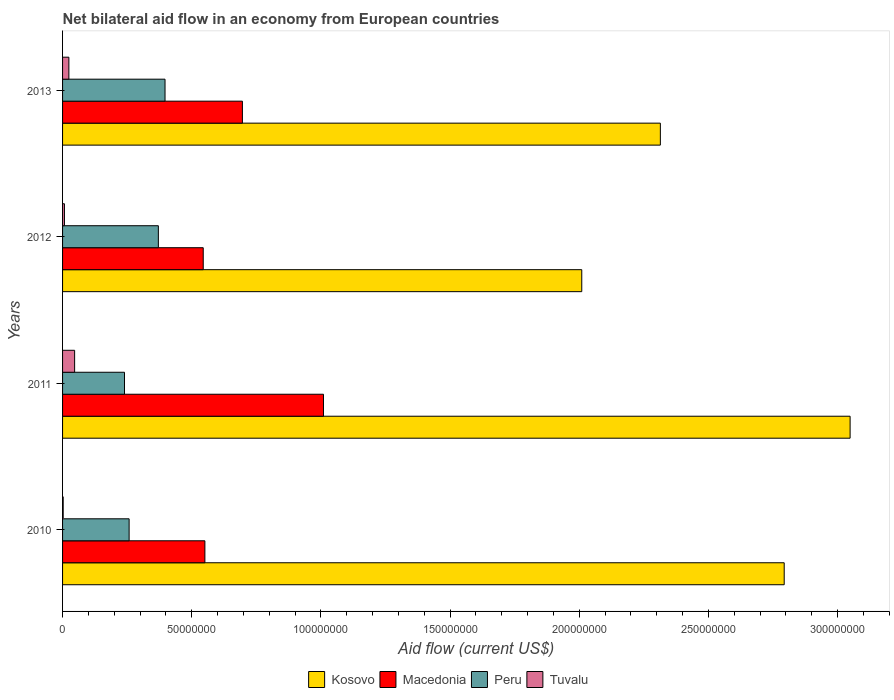How many different coloured bars are there?
Give a very brief answer. 4. How many groups of bars are there?
Keep it short and to the point. 4. Are the number of bars per tick equal to the number of legend labels?
Offer a very short reply. Yes. Are the number of bars on each tick of the Y-axis equal?
Your answer should be very brief. Yes. How many bars are there on the 1st tick from the top?
Make the answer very short. 4. How many bars are there on the 3rd tick from the bottom?
Your response must be concise. 4. What is the net bilateral aid flow in Macedonia in 2011?
Your answer should be very brief. 1.01e+08. Across all years, what is the maximum net bilateral aid flow in Kosovo?
Provide a short and direct response. 3.05e+08. Across all years, what is the minimum net bilateral aid flow in Macedonia?
Ensure brevity in your answer.  5.44e+07. In which year was the net bilateral aid flow in Peru maximum?
Give a very brief answer. 2013. In which year was the net bilateral aid flow in Peru minimum?
Give a very brief answer. 2011. What is the total net bilateral aid flow in Tuvalu in the graph?
Make the answer very short. 8.08e+06. What is the difference between the net bilateral aid flow in Peru in 2010 and that in 2012?
Make the answer very short. -1.13e+07. What is the difference between the net bilateral aid flow in Kosovo in 2013 and the net bilateral aid flow in Peru in 2012?
Your answer should be very brief. 1.94e+08. What is the average net bilateral aid flow in Macedonia per year?
Make the answer very short. 7.00e+07. In the year 2011, what is the difference between the net bilateral aid flow in Macedonia and net bilateral aid flow in Kosovo?
Offer a terse response. -2.04e+08. In how many years, is the net bilateral aid flow in Tuvalu greater than 260000000 US$?
Provide a succinct answer. 0. What is the ratio of the net bilateral aid flow in Macedonia in 2010 to that in 2013?
Offer a terse response. 0.79. Is the net bilateral aid flow in Tuvalu in 2010 less than that in 2013?
Offer a terse response. Yes. What is the difference between the highest and the second highest net bilateral aid flow in Peru?
Ensure brevity in your answer.  2.58e+06. What is the difference between the highest and the lowest net bilateral aid flow in Tuvalu?
Your answer should be very brief. 4.43e+06. Is the sum of the net bilateral aid flow in Kosovo in 2010 and 2011 greater than the maximum net bilateral aid flow in Macedonia across all years?
Ensure brevity in your answer.  Yes. What does the 3rd bar from the top in 2012 represents?
Ensure brevity in your answer.  Macedonia. What does the 2nd bar from the bottom in 2012 represents?
Provide a succinct answer. Macedonia. Is it the case that in every year, the sum of the net bilateral aid flow in Macedonia and net bilateral aid flow in Tuvalu is greater than the net bilateral aid flow in Kosovo?
Make the answer very short. No. How many bars are there?
Your answer should be very brief. 16. Are all the bars in the graph horizontal?
Make the answer very short. Yes. What is the difference between two consecutive major ticks on the X-axis?
Give a very brief answer. 5.00e+07. Are the values on the major ticks of X-axis written in scientific E-notation?
Provide a short and direct response. No. Does the graph contain grids?
Your response must be concise. No. How many legend labels are there?
Give a very brief answer. 4. What is the title of the graph?
Give a very brief answer. Net bilateral aid flow in an economy from European countries. What is the Aid flow (current US$) of Kosovo in 2010?
Provide a succinct answer. 2.79e+08. What is the Aid flow (current US$) of Macedonia in 2010?
Your answer should be compact. 5.51e+07. What is the Aid flow (current US$) in Peru in 2010?
Keep it short and to the point. 2.58e+07. What is the Aid flow (current US$) in Kosovo in 2011?
Offer a very short reply. 3.05e+08. What is the Aid flow (current US$) of Macedonia in 2011?
Offer a very short reply. 1.01e+08. What is the Aid flow (current US$) in Peru in 2011?
Your response must be concise. 2.40e+07. What is the Aid flow (current US$) in Tuvalu in 2011?
Your answer should be very brief. 4.67e+06. What is the Aid flow (current US$) in Kosovo in 2012?
Make the answer very short. 2.01e+08. What is the Aid flow (current US$) of Macedonia in 2012?
Your response must be concise. 5.44e+07. What is the Aid flow (current US$) in Peru in 2012?
Offer a very short reply. 3.71e+07. What is the Aid flow (current US$) in Tuvalu in 2012?
Give a very brief answer. 7.30e+05. What is the Aid flow (current US$) of Kosovo in 2013?
Your answer should be very brief. 2.31e+08. What is the Aid flow (current US$) of Macedonia in 2013?
Provide a succinct answer. 6.96e+07. What is the Aid flow (current US$) in Peru in 2013?
Your answer should be very brief. 3.97e+07. What is the Aid flow (current US$) in Tuvalu in 2013?
Your response must be concise. 2.44e+06. Across all years, what is the maximum Aid flow (current US$) in Kosovo?
Keep it short and to the point. 3.05e+08. Across all years, what is the maximum Aid flow (current US$) in Macedonia?
Ensure brevity in your answer.  1.01e+08. Across all years, what is the maximum Aid flow (current US$) of Peru?
Make the answer very short. 3.97e+07. Across all years, what is the maximum Aid flow (current US$) in Tuvalu?
Keep it short and to the point. 4.67e+06. Across all years, what is the minimum Aid flow (current US$) of Kosovo?
Offer a terse response. 2.01e+08. Across all years, what is the minimum Aid flow (current US$) of Macedonia?
Keep it short and to the point. 5.44e+07. Across all years, what is the minimum Aid flow (current US$) in Peru?
Ensure brevity in your answer.  2.40e+07. Across all years, what is the minimum Aid flow (current US$) in Tuvalu?
Provide a succinct answer. 2.40e+05. What is the total Aid flow (current US$) in Kosovo in the graph?
Give a very brief answer. 1.02e+09. What is the total Aid flow (current US$) of Macedonia in the graph?
Make the answer very short. 2.80e+08. What is the total Aid flow (current US$) in Peru in the graph?
Provide a short and direct response. 1.26e+08. What is the total Aid flow (current US$) in Tuvalu in the graph?
Provide a short and direct response. 8.08e+06. What is the difference between the Aid flow (current US$) of Kosovo in 2010 and that in 2011?
Provide a short and direct response. -2.55e+07. What is the difference between the Aid flow (current US$) in Macedonia in 2010 and that in 2011?
Your response must be concise. -4.59e+07. What is the difference between the Aid flow (current US$) in Peru in 2010 and that in 2011?
Offer a very short reply. 1.79e+06. What is the difference between the Aid flow (current US$) of Tuvalu in 2010 and that in 2011?
Your response must be concise. -4.43e+06. What is the difference between the Aid flow (current US$) of Kosovo in 2010 and that in 2012?
Ensure brevity in your answer.  7.84e+07. What is the difference between the Aid flow (current US$) in Macedonia in 2010 and that in 2012?
Make the answer very short. 6.40e+05. What is the difference between the Aid flow (current US$) in Peru in 2010 and that in 2012?
Ensure brevity in your answer.  -1.13e+07. What is the difference between the Aid flow (current US$) of Tuvalu in 2010 and that in 2012?
Offer a very short reply. -4.90e+05. What is the difference between the Aid flow (current US$) in Kosovo in 2010 and that in 2013?
Your response must be concise. 4.79e+07. What is the difference between the Aid flow (current US$) of Macedonia in 2010 and that in 2013?
Offer a terse response. -1.45e+07. What is the difference between the Aid flow (current US$) of Peru in 2010 and that in 2013?
Your answer should be very brief. -1.39e+07. What is the difference between the Aid flow (current US$) of Tuvalu in 2010 and that in 2013?
Your answer should be very brief. -2.20e+06. What is the difference between the Aid flow (current US$) in Kosovo in 2011 and that in 2012?
Your answer should be very brief. 1.04e+08. What is the difference between the Aid flow (current US$) of Macedonia in 2011 and that in 2012?
Offer a very short reply. 4.65e+07. What is the difference between the Aid flow (current US$) in Peru in 2011 and that in 2012?
Offer a very short reply. -1.31e+07. What is the difference between the Aid flow (current US$) of Tuvalu in 2011 and that in 2012?
Give a very brief answer. 3.94e+06. What is the difference between the Aid flow (current US$) in Kosovo in 2011 and that in 2013?
Offer a very short reply. 7.34e+07. What is the difference between the Aid flow (current US$) of Macedonia in 2011 and that in 2013?
Ensure brevity in your answer.  3.14e+07. What is the difference between the Aid flow (current US$) in Peru in 2011 and that in 2013?
Offer a terse response. -1.57e+07. What is the difference between the Aid flow (current US$) in Tuvalu in 2011 and that in 2013?
Provide a short and direct response. 2.23e+06. What is the difference between the Aid flow (current US$) of Kosovo in 2012 and that in 2013?
Your response must be concise. -3.04e+07. What is the difference between the Aid flow (current US$) of Macedonia in 2012 and that in 2013?
Keep it short and to the point. -1.52e+07. What is the difference between the Aid flow (current US$) of Peru in 2012 and that in 2013?
Your answer should be very brief. -2.58e+06. What is the difference between the Aid flow (current US$) in Tuvalu in 2012 and that in 2013?
Your answer should be compact. -1.71e+06. What is the difference between the Aid flow (current US$) of Kosovo in 2010 and the Aid flow (current US$) of Macedonia in 2011?
Offer a terse response. 1.78e+08. What is the difference between the Aid flow (current US$) in Kosovo in 2010 and the Aid flow (current US$) in Peru in 2011?
Offer a terse response. 2.55e+08. What is the difference between the Aid flow (current US$) in Kosovo in 2010 and the Aid flow (current US$) in Tuvalu in 2011?
Ensure brevity in your answer.  2.75e+08. What is the difference between the Aid flow (current US$) of Macedonia in 2010 and the Aid flow (current US$) of Peru in 2011?
Give a very brief answer. 3.11e+07. What is the difference between the Aid flow (current US$) in Macedonia in 2010 and the Aid flow (current US$) in Tuvalu in 2011?
Provide a short and direct response. 5.04e+07. What is the difference between the Aid flow (current US$) in Peru in 2010 and the Aid flow (current US$) in Tuvalu in 2011?
Your response must be concise. 2.11e+07. What is the difference between the Aid flow (current US$) in Kosovo in 2010 and the Aid flow (current US$) in Macedonia in 2012?
Keep it short and to the point. 2.25e+08. What is the difference between the Aid flow (current US$) in Kosovo in 2010 and the Aid flow (current US$) in Peru in 2012?
Provide a succinct answer. 2.42e+08. What is the difference between the Aid flow (current US$) in Kosovo in 2010 and the Aid flow (current US$) in Tuvalu in 2012?
Your answer should be very brief. 2.79e+08. What is the difference between the Aid flow (current US$) of Macedonia in 2010 and the Aid flow (current US$) of Peru in 2012?
Give a very brief answer. 1.80e+07. What is the difference between the Aid flow (current US$) in Macedonia in 2010 and the Aid flow (current US$) in Tuvalu in 2012?
Your response must be concise. 5.44e+07. What is the difference between the Aid flow (current US$) in Peru in 2010 and the Aid flow (current US$) in Tuvalu in 2012?
Your response must be concise. 2.50e+07. What is the difference between the Aid flow (current US$) of Kosovo in 2010 and the Aid flow (current US$) of Macedonia in 2013?
Give a very brief answer. 2.10e+08. What is the difference between the Aid flow (current US$) of Kosovo in 2010 and the Aid flow (current US$) of Peru in 2013?
Your response must be concise. 2.40e+08. What is the difference between the Aid flow (current US$) in Kosovo in 2010 and the Aid flow (current US$) in Tuvalu in 2013?
Make the answer very short. 2.77e+08. What is the difference between the Aid flow (current US$) in Macedonia in 2010 and the Aid flow (current US$) in Peru in 2013?
Your answer should be very brief. 1.54e+07. What is the difference between the Aid flow (current US$) of Macedonia in 2010 and the Aid flow (current US$) of Tuvalu in 2013?
Give a very brief answer. 5.26e+07. What is the difference between the Aid flow (current US$) of Peru in 2010 and the Aid flow (current US$) of Tuvalu in 2013?
Your answer should be very brief. 2.33e+07. What is the difference between the Aid flow (current US$) in Kosovo in 2011 and the Aid flow (current US$) in Macedonia in 2012?
Offer a terse response. 2.50e+08. What is the difference between the Aid flow (current US$) in Kosovo in 2011 and the Aid flow (current US$) in Peru in 2012?
Offer a terse response. 2.68e+08. What is the difference between the Aid flow (current US$) in Kosovo in 2011 and the Aid flow (current US$) in Tuvalu in 2012?
Ensure brevity in your answer.  3.04e+08. What is the difference between the Aid flow (current US$) in Macedonia in 2011 and the Aid flow (current US$) in Peru in 2012?
Make the answer very short. 6.39e+07. What is the difference between the Aid flow (current US$) in Macedonia in 2011 and the Aid flow (current US$) in Tuvalu in 2012?
Provide a succinct answer. 1.00e+08. What is the difference between the Aid flow (current US$) in Peru in 2011 and the Aid flow (current US$) in Tuvalu in 2012?
Your response must be concise. 2.32e+07. What is the difference between the Aid flow (current US$) in Kosovo in 2011 and the Aid flow (current US$) in Macedonia in 2013?
Your answer should be compact. 2.35e+08. What is the difference between the Aid flow (current US$) in Kosovo in 2011 and the Aid flow (current US$) in Peru in 2013?
Your response must be concise. 2.65e+08. What is the difference between the Aid flow (current US$) in Kosovo in 2011 and the Aid flow (current US$) in Tuvalu in 2013?
Provide a short and direct response. 3.02e+08. What is the difference between the Aid flow (current US$) in Macedonia in 2011 and the Aid flow (current US$) in Peru in 2013?
Your answer should be very brief. 6.13e+07. What is the difference between the Aid flow (current US$) of Macedonia in 2011 and the Aid flow (current US$) of Tuvalu in 2013?
Your answer should be very brief. 9.86e+07. What is the difference between the Aid flow (current US$) of Peru in 2011 and the Aid flow (current US$) of Tuvalu in 2013?
Your answer should be compact. 2.15e+07. What is the difference between the Aid flow (current US$) in Kosovo in 2012 and the Aid flow (current US$) in Macedonia in 2013?
Provide a short and direct response. 1.31e+08. What is the difference between the Aid flow (current US$) in Kosovo in 2012 and the Aid flow (current US$) in Peru in 2013?
Make the answer very short. 1.61e+08. What is the difference between the Aid flow (current US$) in Kosovo in 2012 and the Aid flow (current US$) in Tuvalu in 2013?
Your response must be concise. 1.99e+08. What is the difference between the Aid flow (current US$) in Macedonia in 2012 and the Aid flow (current US$) in Peru in 2013?
Make the answer very short. 1.48e+07. What is the difference between the Aid flow (current US$) in Macedonia in 2012 and the Aid flow (current US$) in Tuvalu in 2013?
Provide a short and direct response. 5.20e+07. What is the difference between the Aid flow (current US$) in Peru in 2012 and the Aid flow (current US$) in Tuvalu in 2013?
Offer a very short reply. 3.46e+07. What is the average Aid flow (current US$) of Kosovo per year?
Keep it short and to the point. 2.54e+08. What is the average Aid flow (current US$) in Macedonia per year?
Ensure brevity in your answer.  7.00e+07. What is the average Aid flow (current US$) in Peru per year?
Your answer should be compact. 3.16e+07. What is the average Aid flow (current US$) of Tuvalu per year?
Provide a succinct answer. 2.02e+06. In the year 2010, what is the difference between the Aid flow (current US$) of Kosovo and Aid flow (current US$) of Macedonia?
Your answer should be very brief. 2.24e+08. In the year 2010, what is the difference between the Aid flow (current US$) of Kosovo and Aid flow (current US$) of Peru?
Your response must be concise. 2.54e+08. In the year 2010, what is the difference between the Aid flow (current US$) of Kosovo and Aid flow (current US$) of Tuvalu?
Offer a terse response. 2.79e+08. In the year 2010, what is the difference between the Aid flow (current US$) of Macedonia and Aid flow (current US$) of Peru?
Provide a succinct answer. 2.93e+07. In the year 2010, what is the difference between the Aid flow (current US$) in Macedonia and Aid flow (current US$) in Tuvalu?
Provide a succinct answer. 5.48e+07. In the year 2010, what is the difference between the Aid flow (current US$) of Peru and Aid flow (current US$) of Tuvalu?
Give a very brief answer. 2.55e+07. In the year 2011, what is the difference between the Aid flow (current US$) in Kosovo and Aid flow (current US$) in Macedonia?
Offer a terse response. 2.04e+08. In the year 2011, what is the difference between the Aid flow (current US$) in Kosovo and Aid flow (current US$) in Peru?
Keep it short and to the point. 2.81e+08. In the year 2011, what is the difference between the Aid flow (current US$) of Kosovo and Aid flow (current US$) of Tuvalu?
Your answer should be compact. 3.00e+08. In the year 2011, what is the difference between the Aid flow (current US$) of Macedonia and Aid flow (current US$) of Peru?
Ensure brevity in your answer.  7.70e+07. In the year 2011, what is the difference between the Aid flow (current US$) of Macedonia and Aid flow (current US$) of Tuvalu?
Offer a very short reply. 9.63e+07. In the year 2011, what is the difference between the Aid flow (current US$) of Peru and Aid flow (current US$) of Tuvalu?
Offer a very short reply. 1.93e+07. In the year 2012, what is the difference between the Aid flow (current US$) in Kosovo and Aid flow (current US$) in Macedonia?
Provide a succinct answer. 1.47e+08. In the year 2012, what is the difference between the Aid flow (current US$) in Kosovo and Aid flow (current US$) in Peru?
Your answer should be compact. 1.64e+08. In the year 2012, what is the difference between the Aid flow (current US$) of Kosovo and Aid flow (current US$) of Tuvalu?
Offer a very short reply. 2.00e+08. In the year 2012, what is the difference between the Aid flow (current US$) in Macedonia and Aid flow (current US$) in Peru?
Provide a short and direct response. 1.74e+07. In the year 2012, what is the difference between the Aid flow (current US$) of Macedonia and Aid flow (current US$) of Tuvalu?
Your response must be concise. 5.37e+07. In the year 2012, what is the difference between the Aid flow (current US$) in Peru and Aid flow (current US$) in Tuvalu?
Ensure brevity in your answer.  3.64e+07. In the year 2013, what is the difference between the Aid flow (current US$) of Kosovo and Aid flow (current US$) of Macedonia?
Make the answer very short. 1.62e+08. In the year 2013, what is the difference between the Aid flow (current US$) in Kosovo and Aid flow (current US$) in Peru?
Ensure brevity in your answer.  1.92e+08. In the year 2013, what is the difference between the Aid flow (current US$) of Kosovo and Aid flow (current US$) of Tuvalu?
Provide a succinct answer. 2.29e+08. In the year 2013, what is the difference between the Aid flow (current US$) in Macedonia and Aid flow (current US$) in Peru?
Make the answer very short. 3.00e+07. In the year 2013, what is the difference between the Aid flow (current US$) of Macedonia and Aid flow (current US$) of Tuvalu?
Give a very brief answer. 6.72e+07. In the year 2013, what is the difference between the Aid flow (current US$) of Peru and Aid flow (current US$) of Tuvalu?
Ensure brevity in your answer.  3.72e+07. What is the ratio of the Aid flow (current US$) in Kosovo in 2010 to that in 2011?
Your response must be concise. 0.92. What is the ratio of the Aid flow (current US$) in Macedonia in 2010 to that in 2011?
Give a very brief answer. 0.55. What is the ratio of the Aid flow (current US$) of Peru in 2010 to that in 2011?
Keep it short and to the point. 1.07. What is the ratio of the Aid flow (current US$) in Tuvalu in 2010 to that in 2011?
Ensure brevity in your answer.  0.05. What is the ratio of the Aid flow (current US$) in Kosovo in 2010 to that in 2012?
Your response must be concise. 1.39. What is the ratio of the Aid flow (current US$) of Macedonia in 2010 to that in 2012?
Your answer should be compact. 1.01. What is the ratio of the Aid flow (current US$) in Peru in 2010 to that in 2012?
Make the answer very short. 0.69. What is the ratio of the Aid flow (current US$) of Tuvalu in 2010 to that in 2012?
Offer a very short reply. 0.33. What is the ratio of the Aid flow (current US$) of Kosovo in 2010 to that in 2013?
Offer a terse response. 1.21. What is the ratio of the Aid flow (current US$) of Macedonia in 2010 to that in 2013?
Your response must be concise. 0.79. What is the ratio of the Aid flow (current US$) of Peru in 2010 to that in 2013?
Your answer should be compact. 0.65. What is the ratio of the Aid flow (current US$) in Tuvalu in 2010 to that in 2013?
Keep it short and to the point. 0.1. What is the ratio of the Aid flow (current US$) in Kosovo in 2011 to that in 2012?
Keep it short and to the point. 1.52. What is the ratio of the Aid flow (current US$) of Macedonia in 2011 to that in 2012?
Your response must be concise. 1.85. What is the ratio of the Aid flow (current US$) of Peru in 2011 to that in 2012?
Your answer should be very brief. 0.65. What is the ratio of the Aid flow (current US$) in Tuvalu in 2011 to that in 2012?
Your answer should be compact. 6.4. What is the ratio of the Aid flow (current US$) of Kosovo in 2011 to that in 2013?
Provide a succinct answer. 1.32. What is the ratio of the Aid flow (current US$) of Macedonia in 2011 to that in 2013?
Ensure brevity in your answer.  1.45. What is the ratio of the Aid flow (current US$) of Peru in 2011 to that in 2013?
Ensure brevity in your answer.  0.6. What is the ratio of the Aid flow (current US$) of Tuvalu in 2011 to that in 2013?
Give a very brief answer. 1.91. What is the ratio of the Aid flow (current US$) of Kosovo in 2012 to that in 2013?
Offer a very short reply. 0.87. What is the ratio of the Aid flow (current US$) in Macedonia in 2012 to that in 2013?
Provide a succinct answer. 0.78. What is the ratio of the Aid flow (current US$) of Peru in 2012 to that in 2013?
Offer a terse response. 0.93. What is the ratio of the Aid flow (current US$) of Tuvalu in 2012 to that in 2013?
Your response must be concise. 0.3. What is the difference between the highest and the second highest Aid flow (current US$) in Kosovo?
Provide a succinct answer. 2.55e+07. What is the difference between the highest and the second highest Aid flow (current US$) of Macedonia?
Keep it short and to the point. 3.14e+07. What is the difference between the highest and the second highest Aid flow (current US$) of Peru?
Give a very brief answer. 2.58e+06. What is the difference between the highest and the second highest Aid flow (current US$) of Tuvalu?
Provide a short and direct response. 2.23e+06. What is the difference between the highest and the lowest Aid flow (current US$) of Kosovo?
Offer a very short reply. 1.04e+08. What is the difference between the highest and the lowest Aid flow (current US$) in Macedonia?
Offer a very short reply. 4.65e+07. What is the difference between the highest and the lowest Aid flow (current US$) of Peru?
Your response must be concise. 1.57e+07. What is the difference between the highest and the lowest Aid flow (current US$) in Tuvalu?
Give a very brief answer. 4.43e+06. 